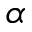<formula> <loc_0><loc_0><loc_500><loc_500>\alpha</formula> 